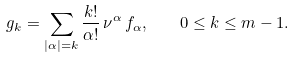<formula> <loc_0><loc_0><loc_500><loc_500>g _ { k } = \sum _ { | \alpha | = k } \frac { k ! } { \alpha ! } \, \nu ^ { \alpha } \, f _ { \alpha } , \quad 0 \leq k \leq m - 1 .</formula> 